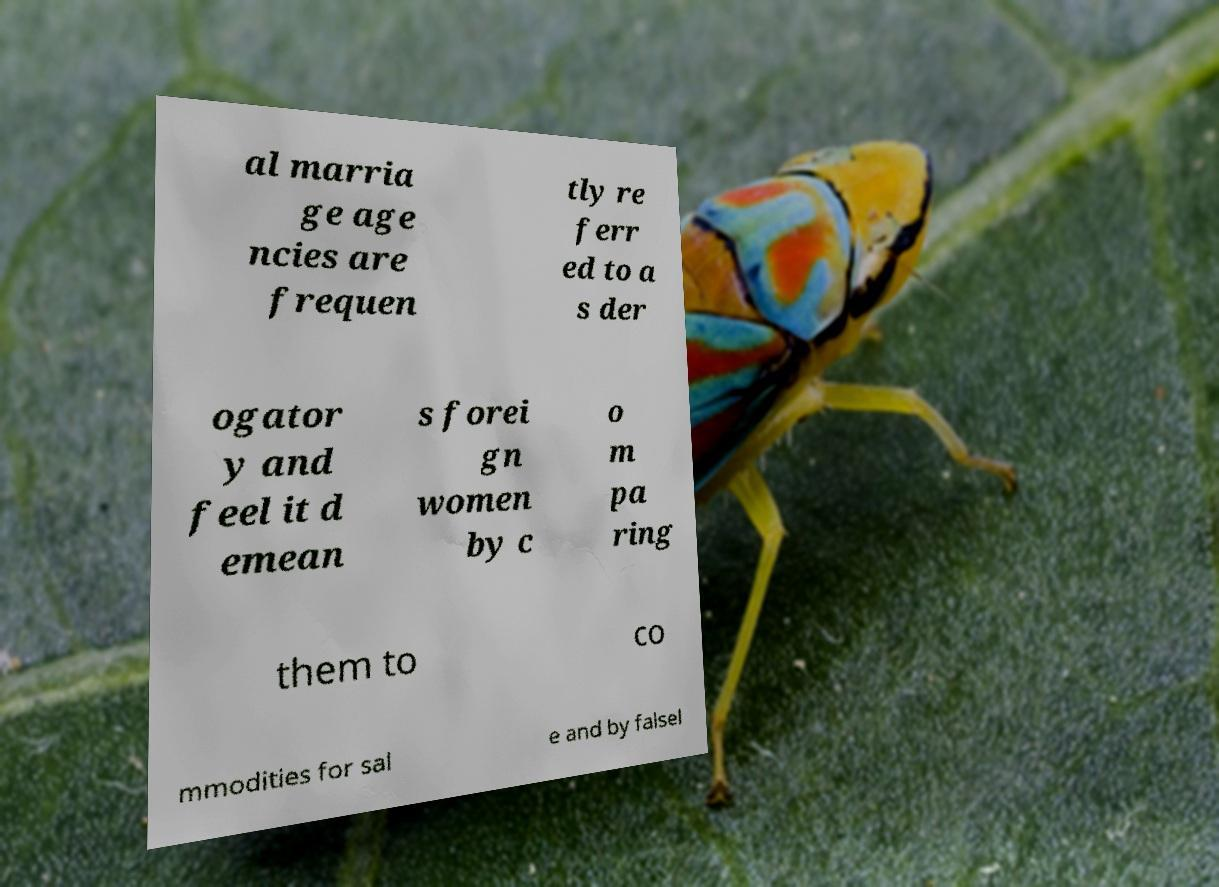Please identify and transcribe the text found in this image. al marria ge age ncies are frequen tly re ferr ed to a s der ogator y and feel it d emean s forei gn women by c o m pa ring them to co mmodities for sal e and by falsel 